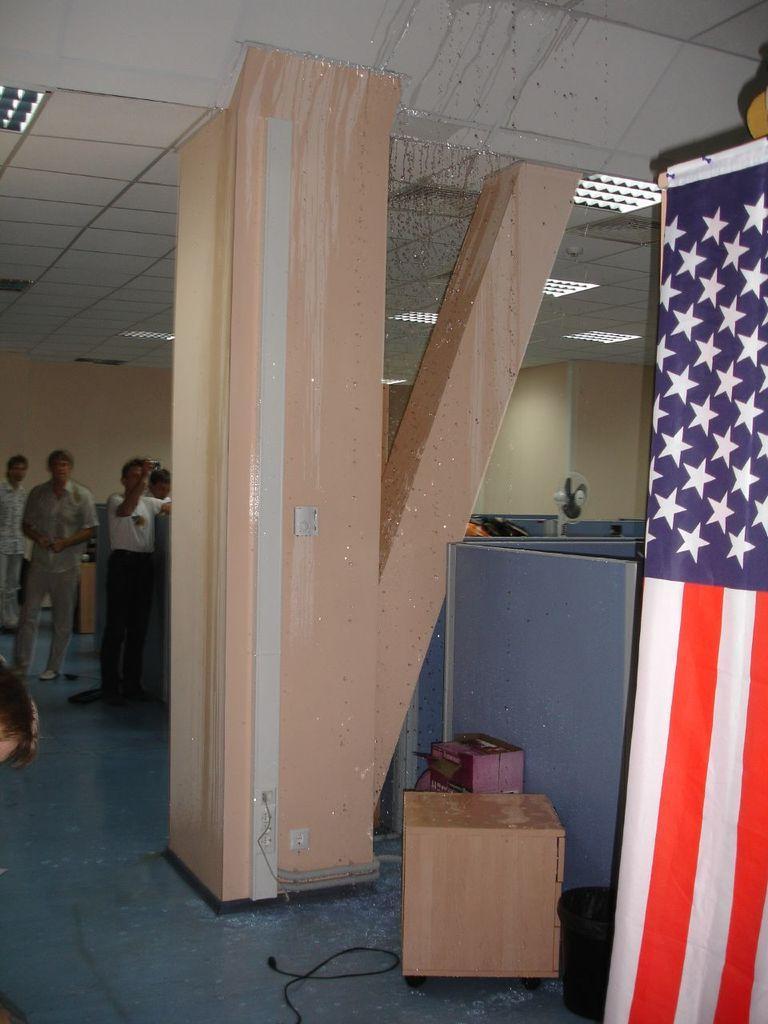Please provide a concise description of this image. In the center of the image there is a pillar. In the background of the image there are people standing. There is a box at the bottom of the image. There is a flag. 